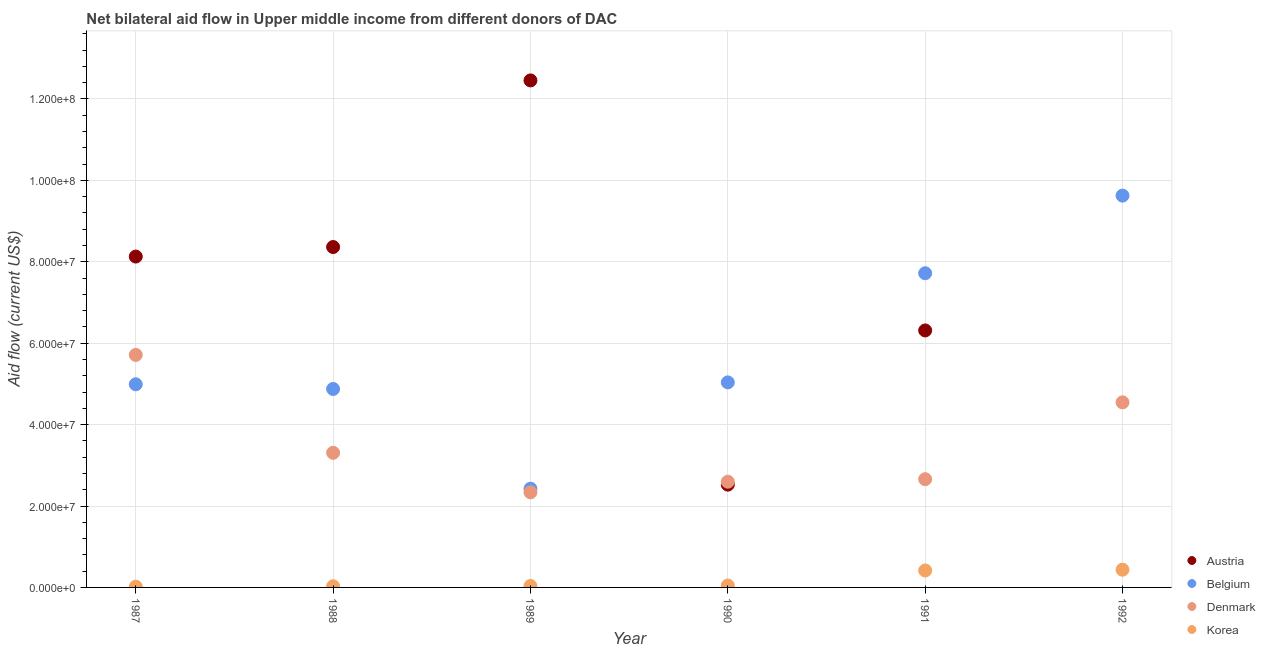Is the number of dotlines equal to the number of legend labels?
Offer a terse response. No. What is the amount of aid given by austria in 1987?
Your answer should be very brief. 8.13e+07. Across all years, what is the maximum amount of aid given by korea?
Ensure brevity in your answer.  4.35e+06. Across all years, what is the minimum amount of aid given by korea?
Your answer should be compact. 1.80e+05. What is the total amount of aid given by austria in the graph?
Your answer should be very brief. 3.78e+08. What is the difference between the amount of aid given by denmark in 1988 and that in 1990?
Ensure brevity in your answer.  7.10e+06. What is the difference between the amount of aid given by korea in 1989 and the amount of aid given by austria in 1990?
Your answer should be compact. -2.49e+07. What is the average amount of aid given by korea per year?
Your answer should be very brief. 1.64e+06. In the year 1992, what is the difference between the amount of aid given by korea and amount of aid given by belgium?
Offer a very short reply. -9.19e+07. What is the ratio of the amount of aid given by korea in 1987 to that in 1991?
Keep it short and to the point. 0.04. Is the amount of aid given by austria in 1988 less than that in 1989?
Your answer should be compact. Yes. Is the difference between the amount of aid given by austria in 1987 and 1990 greater than the difference between the amount of aid given by denmark in 1987 and 1990?
Your answer should be very brief. Yes. What is the difference between the highest and the second highest amount of aid given by korea?
Your answer should be compact. 1.90e+05. What is the difference between the highest and the lowest amount of aid given by denmark?
Make the answer very short. 3.37e+07. In how many years, is the amount of aid given by belgium greater than the average amount of aid given by belgium taken over all years?
Your answer should be very brief. 2. Is the sum of the amount of aid given by austria in 1990 and 1991 greater than the maximum amount of aid given by belgium across all years?
Ensure brevity in your answer.  No. Is it the case that in every year, the sum of the amount of aid given by austria and amount of aid given by belgium is greater than the amount of aid given by denmark?
Give a very brief answer. Yes. Is the amount of aid given by korea strictly less than the amount of aid given by denmark over the years?
Keep it short and to the point. Yes. How many years are there in the graph?
Offer a very short reply. 6. Are the values on the major ticks of Y-axis written in scientific E-notation?
Give a very brief answer. Yes. Does the graph contain grids?
Make the answer very short. Yes. How many legend labels are there?
Your answer should be very brief. 4. What is the title of the graph?
Provide a short and direct response. Net bilateral aid flow in Upper middle income from different donors of DAC. Does "Regional development banks" appear as one of the legend labels in the graph?
Provide a short and direct response. No. What is the label or title of the X-axis?
Offer a very short reply. Year. What is the Aid flow (current US$) in Austria in 1987?
Ensure brevity in your answer.  8.13e+07. What is the Aid flow (current US$) of Belgium in 1987?
Provide a short and direct response. 4.99e+07. What is the Aid flow (current US$) in Denmark in 1987?
Offer a very short reply. 5.71e+07. What is the Aid flow (current US$) of Korea in 1987?
Provide a short and direct response. 1.80e+05. What is the Aid flow (current US$) of Austria in 1988?
Offer a terse response. 8.36e+07. What is the Aid flow (current US$) of Belgium in 1988?
Keep it short and to the point. 4.88e+07. What is the Aid flow (current US$) in Denmark in 1988?
Your answer should be compact. 3.31e+07. What is the Aid flow (current US$) in Korea in 1988?
Give a very brief answer. 2.90e+05. What is the Aid flow (current US$) in Austria in 1989?
Offer a terse response. 1.25e+08. What is the Aid flow (current US$) in Belgium in 1989?
Keep it short and to the point. 2.42e+07. What is the Aid flow (current US$) of Denmark in 1989?
Make the answer very short. 2.34e+07. What is the Aid flow (current US$) in Austria in 1990?
Offer a terse response. 2.52e+07. What is the Aid flow (current US$) in Belgium in 1990?
Provide a short and direct response. 5.04e+07. What is the Aid flow (current US$) in Denmark in 1990?
Your answer should be compact. 2.60e+07. What is the Aid flow (current US$) in Korea in 1990?
Provide a succinct answer. 4.70e+05. What is the Aid flow (current US$) in Austria in 1991?
Give a very brief answer. 6.31e+07. What is the Aid flow (current US$) in Belgium in 1991?
Provide a succinct answer. 7.72e+07. What is the Aid flow (current US$) of Denmark in 1991?
Provide a succinct answer. 2.66e+07. What is the Aid flow (current US$) in Korea in 1991?
Provide a short and direct response. 4.16e+06. What is the Aid flow (current US$) in Austria in 1992?
Provide a short and direct response. 0. What is the Aid flow (current US$) in Belgium in 1992?
Offer a terse response. 9.62e+07. What is the Aid flow (current US$) in Denmark in 1992?
Ensure brevity in your answer.  4.55e+07. What is the Aid flow (current US$) in Korea in 1992?
Your response must be concise. 4.35e+06. Across all years, what is the maximum Aid flow (current US$) in Austria?
Your answer should be compact. 1.25e+08. Across all years, what is the maximum Aid flow (current US$) in Belgium?
Provide a short and direct response. 9.62e+07. Across all years, what is the maximum Aid flow (current US$) of Denmark?
Give a very brief answer. 5.71e+07. Across all years, what is the maximum Aid flow (current US$) in Korea?
Your answer should be very brief. 4.35e+06. Across all years, what is the minimum Aid flow (current US$) of Austria?
Offer a terse response. 0. Across all years, what is the minimum Aid flow (current US$) of Belgium?
Your response must be concise. 2.42e+07. Across all years, what is the minimum Aid flow (current US$) of Denmark?
Provide a succinct answer. 2.34e+07. What is the total Aid flow (current US$) in Austria in the graph?
Offer a very short reply. 3.78e+08. What is the total Aid flow (current US$) in Belgium in the graph?
Provide a short and direct response. 3.47e+08. What is the total Aid flow (current US$) of Denmark in the graph?
Provide a short and direct response. 2.12e+08. What is the total Aid flow (current US$) of Korea in the graph?
Keep it short and to the point. 9.81e+06. What is the difference between the Aid flow (current US$) in Austria in 1987 and that in 1988?
Ensure brevity in your answer.  -2.34e+06. What is the difference between the Aid flow (current US$) of Belgium in 1987 and that in 1988?
Ensure brevity in your answer.  1.15e+06. What is the difference between the Aid flow (current US$) in Denmark in 1987 and that in 1988?
Give a very brief answer. 2.40e+07. What is the difference between the Aid flow (current US$) in Austria in 1987 and that in 1989?
Provide a short and direct response. -4.33e+07. What is the difference between the Aid flow (current US$) of Belgium in 1987 and that in 1989?
Offer a terse response. 2.56e+07. What is the difference between the Aid flow (current US$) of Denmark in 1987 and that in 1989?
Provide a short and direct response. 3.37e+07. What is the difference between the Aid flow (current US$) in Austria in 1987 and that in 1990?
Make the answer very short. 5.60e+07. What is the difference between the Aid flow (current US$) in Belgium in 1987 and that in 1990?
Provide a succinct answer. -4.70e+05. What is the difference between the Aid flow (current US$) of Denmark in 1987 and that in 1990?
Your response must be concise. 3.12e+07. What is the difference between the Aid flow (current US$) in Korea in 1987 and that in 1990?
Give a very brief answer. -2.90e+05. What is the difference between the Aid flow (current US$) in Austria in 1987 and that in 1991?
Provide a short and direct response. 1.82e+07. What is the difference between the Aid flow (current US$) of Belgium in 1987 and that in 1991?
Ensure brevity in your answer.  -2.73e+07. What is the difference between the Aid flow (current US$) in Denmark in 1987 and that in 1991?
Keep it short and to the point. 3.05e+07. What is the difference between the Aid flow (current US$) of Korea in 1987 and that in 1991?
Offer a terse response. -3.98e+06. What is the difference between the Aid flow (current US$) in Belgium in 1987 and that in 1992?
Make the answer very short. -4.64e+07. What is the difference between the Aid flow (current US$) in Denmark in 1987 and that in 1992?
Ensure brevity in your answer.  1.16e+07. What is the difference between the Aid flow (current US$) in Korea in 1987 and that in 1992?
Give a very brief answer. -4.17e+06. What is the difference between the Aid flow (current US$) of Austria in 1988 and that in 1989?
Your answer should be compact. -4.09e+07. What is the difference between the Aid flow (current US$) in Belgium in 1988 and that in 1989?
Your answer should be compact. 2.45e+07. What is the difference between the Aid flow (current US$) of Denmark in 1988 and that in 1989?
Offer a terse response. 9.69e+06. What is the difference between the Aid flow (current US$) of Austria in 1988 and that in 1990?
Provide a succinct answer. 5.84e+07. What is the difference between the Aid flow (current US$) of Belgium in 1988 and that in 1990?
Offer a terse response. -1.62e+06. What is the difference between the Aid flow (current US$) of Denmark in 1988 and that in 1990?
Provide a short and direct response. 7.10e+06. What is the difference between the Aid flow (current US$) of Austria in 1988 and that in 1991?
Your answer should be very brief. 2.05e+07. What is the difference between the Aid flow (current US$) of Belgium in 1988 and that in 1991?
Your answer should be very brief. -2.84e+07. What is the difference between the Aid flow (current US$) of Denmark in 1988 and that in 1991?
Offer a terse response. 6.48e+06. What is the difference between the Aid flow (current US$) in Korea in 1988 and that in 1991?
Keep it short and to the point. -3.87e+06. What is the difference between the Aid flow (current US$) in Belgium in 1988 and that in 1992?
Ensure brevity in your answer.  -4.75e+07. What is the difference between the Aid flow (current US$) of Denmark in 1988 and that in 1992?
Offer a terse response. -1.24e+07. What is the difference between the Aid flow (current US$) in Korea in 1988 and that in 1992?
Keep it short and to the point. -4.06e+06. What is the difference between the Aid flow (current US$) in Austria in 1989 and that in 1990?
Give a very brief answer. 9.93e+07. What is the difference between the Aid flow (current US$) of Belgium in 1989 and that in 1990?
Make the answer very short. -2.61e+07. What is the difference between the Aid flow (current US$) in Denmark in 1989 and that in 1990?
Keep it short and to the point. -2.59e+06. What is the difference between the Aid flow (current US$) in Korea in 1989 and that in 1990?
Provide a short and direct response. -1.10e+05. What is the difference between the Aid flow (current US$) in Austria in 1989 and that in 1991?
Offer a terse response. 6.14e+07. What is the difference between the Aid flow (current US$) of Belgium in 1989 and that in 1991?
Make the answer very short. -5.29e+07. What is the difference between the Aid flow (current US$) in Denmark in 1989 and that in 1991?
Offer a terse response. -3.21e+06. What is the difference between the Aid flow (current US$) of Korea in 1989 and that in 1991?
Offer a terse response. -3.80e+06. What is the difference between the Aid flow (current US$) of Belgium in 1989 and that in 1992?
Give a very brief answer. -7.20e+07. What is the difference between the Aid flow (current US$) in Denmark in 1989 and that in 1992?
Provide a short and direct response. -2.21e+07. What is the difference between the Aid flow (current US$) of Korea in 1989 and that in 1992?
Make the answer very short. -3.99e+06. What is the difference between the Aid flow (current US$) in Austria in 1990 and that in 1991?
Keep it short and to the point. -3.79e+07. What is the difference between the Aid flow (current US$) in Belgium in 1990 and that in 1991?
Offer a very short reply. -2.68e+07. What is the difference between the Aid flow (current US$) of Denmark in 1990 and that in 1991?
Provide a short and direct response. -6.20e+05. What is the difference between the Aid flow (current US$) of Korea in 1990 and that in 1991?
Offer a very short reply. -3.69e+06. What is the difference between the Aid flow (current US$) in Belgium in 1990 and that in 1992?
Provide a succinct answer. -4.59e+07. What is the difference between the Aid flow (current US$) in Denmark in 1990 and that in 1992?
Your answer should be compact. -1.95e+07. What is the difference between the Aid flow (current US$) in Korea in 1990 and that in 1992?
Your response must be concise. -3.88e+06. What is the difference between the Aid flow (current US$) in Belgium in 1991 and that in 1992?
Ensure brevity in your answer.  -1.91e+07. What is the difference between the Aid flow (current US$) of Denmark in 1991 and that in 1992?
Your answer should be very brief. -1.89e+07. What is the difference between the Aid flow (current US$) in Korea in 1991 and that in 1992?
Provide a succinct answer. -1.90e+05. What is the difference between the Aid flow (current US$) of Austria in 1987 and the Aid flow (current US$) of Belgium in 1988?
Give a very brief answer. 3.25e+07. What is the difference between the Aid flow (current US$) of Austria in 1987 and the Aid flow (current US$) of Denmark in 1988?
Give a very brief answer. 4.82e+07. What is the difference between the Aid flow (current US$) in Austria in 1987 and the Aid flow (current US$) in Korea in 1988?
Ensure brevity in your answer.  8.10e+07. What is the difference between the Aid flow (current US$) in Belgium in 1987 and the Aid flow (current US$) in Denmark in 1988?
Give a very brief answer. 1.68e+07. What is the difference between the Aid flow (current US$) in Belgium in 1987 and the Aid flow (current US$) in Korea in 1988?
Offer a very short reply. 4.96e+07. What is the difference between the Aid flow (current US$) in Denmark in 1987 and the Aid flow (current US$) in Korea in 1988?
Give a very brief answer. 5.68e+07. What is the difference between the Aid flow (current US$) of Austria in 1987 and the Aid flow (current US$) of Belgium in 1989?
Offer a terse response. 5.70e+07. What is the difference between the Aid flow (current US$) in Austria in 1987 and the Aid flow (current US$) in Denmark in 1989?
Offer a very short reply. 5.79e+07. What is the difference between the Aid flow (current US$) in Austria in 1987 and the Aid flow (current US$) in Korea in 1989?
Give a very brief answer. 8.09e+07. What is the difference between the Aid flow (current US$) of Belgium in 1987 and the Aid flow (current US$) of Denmark in 1989?
Your response must be concise. 2.65e+07. What is the difference between the Aid flow (current US$) in Belgium in 1987 and the Aid flow (current US$) in Korea in 1989?
Keep it short and to the point. 4.95e+07. What is the difference between the Aid flow (current US$) in Denmark in 1987 and the Aid flow (current US$) in Korea in 1989?
Your response must be concise. 5.68e+07. What is the difference between the Aid flow (current US$) of Austria in 1987 and the Aid flow (current US$) of Belgium in 1990?
Offer a terse response. 3.09e+07. What is the difference between the Aid flow (current US$) in Austria in 1987 and the Aid flow (current US$) in Denmark in 1990?
Ensure brevity in your answer.  5.53e+07. What is the difference between the Aid flow (current US$) of Austria in 1987 and the Aid flow (current US$) of Korea in 1990?
Offer a very short reply. 8.08e+07. What is the difference between the Aid flow (current US$) of Belgium in 1987 and the Aid flow (current US$) of Denmark in 1990?
Give a very brief answer. 2.39e+07. What is the difference between the Aid flow (current US$) in Belgium in 1987 and the Aid flow (current US$) in Korea in 1990?
Make the answer very short. 4.94e+07. What is the difference between the Aid flow (current US$) in Denmark in 1987 and the Aid flow (current US$) in Korea in 1990?
Your answer should be very brief. 5.66e+07. What is the difference between the Aid flow (current US$) in Austria in 1987 and the Aid flow (current US$) in Belgium in 1991?
Offer a terse response. 4.10e+06. What is the difference between the Aid flow (current US$) in Austria in 1987 and the Aid flow (current US$) in Denmark in 1991?
Provide a short and direct response. 5.47e+07. What is the difference between the Aid flow (current US$) in Austria in 1987 and the Aid flow (current US$) in Korea in 1991?
Provide a short and direct response. 7.71e+07. What is the difference between the Aid flow (current US$) of Belgium in 1987 and the Aid flow (current US$) of Denmark in 1991?
Your answer should be very brief. 2.33e+07. What is the difference between the Aid flow (current US$) in Belgium in 1987 and the Aid flow (current US$) in Korea in 1991?
Your answer should be very brief. 4.57e+07. What is the difference between the Aid flow (current US$) of Denmark in 1987 and the Aid flow (current US$) of Korea in 1991?
Keep it short and to the point. 5.30e+07. What is the difference between the Aid flow (current US$) of Austria in 1987 and the Aid flow (current US$) of Belgium in 1992?
Make the answer very short. -1.50e+07. What is the difference between the Aid flow (current US$) of Austria in 1987 and the Aid flow (current US$) of Denmark in 1992?
Your answer should be very brief. 3.58e+07. What is the difference between the Aid flow (current US$) of Austria in 1987 and the Aid flow (current US$) of Korea in 1992?
Your response must be concise. 7.69e+07. What is the difference between the Aid flow (current US$) of Belgium in 1987 and the Aid flow (current US$) of Denmark in 1992?
Give a very brief answer. 4.43e+06. What is the difference between the Aid flow (current US$) of Belgium in 1987 and the Aid flow (current US$) of Korea in 1992?
Your answer should be very brief. 4.56e+07. What is the difference between the Aid flow (current US$) of Denmark in 1987 and the Aid flow (current US$) of Korea in 1992?
Keep it short and to the point. 5.28e+07. What is the difference between the Aid flow (current US$) in Austria in 1988 and the Aid flow (current US$) in Belgium in 1989?
Keep it short and to the point. 5.94e+07. What is the difference between the Aid flow (current US$) of Austria in 1988 and the Aid flow (current US$) of Denmark in 1989?
Your response must be concise. 6.02e+07. What is the difference between the Aid flow (current US$) of Austria in 1988 and the Aid flow (current US$) of Korea in 1989?
Your response must be concise. 8.33e+07. What is the difference between the Aid flow (current US$) of Belgium in 1988 and the Aid flow (current US$) of Denmark in 1989?
Ensure brevity in your answer.  2.54e+07. What is the difference between the Aid flow (current US$) of Belgium in 1988 and the Aid flow (current US$) of Korea in 1989?
Provide a short and direct response. 4.84e+07. What is the difference between the Aid flow (current US$) in Denmark in 1988 and the Aid flow (current US$) in Korea in 1989?
Make the answer very short. 3.27e+07. What is the difference between the Aid flow (current US$) in Austria in 1988 and the Aid flow (current US$) in Belgium in 1990?
Your answer should be compact. 3.32e+07. What is the difference between the Aid flow (current US$) of Austria in 1988 and the Aid flow (current US$) of Denmark in 1990?
Keep it short and to the point. 5.76e+07. What is the difference between the Aid flow (current US$) of Austria in 1988 and the Aid flow (current US$) of Korea in 1990?
Your response must be concise. 8.32e+07. What is the difference between the Aid flow (current US$) of Belgium in 1988 and the Aid flow (current US$) of Denmark in 1990?
Give a very brief answer. 2.28e+07. What is the difference between the Aid flow (current US$) in Belgium in 1988 and the Aid flow (current US$) in Korea in 1990?
Your response must be concise. 4.83e+07. What is the difference between the Aid flow (current US$) of Denmark in 1988 and the Aid flow (current US$) of Korea in 1990?
Ensure brevity in your answer.  3.26e+07. What is the difference between the Aid flow (current US$) in Austria in 1988 and the Aid flow (current US$) in Belgium in 1991?
Keep it short and to the point. 6.44e+06. What is the difference between the Aid flow (current US$) of Austria in 1988 and the Aid flow (current US$) of Denmark in 1991?
Offer a terse response. 5.70e+07. What is the difference between the Aid flow (current US$) in Austria in 1988 and the Aid flow (current US$) in Korea in 1991?
Your answer should be compact. 7.95e+07. What is the difference between the Aid flow (current US$) in Belgium in 1988 and the Aid flow (current US$) in Denmark in 1991?
Provide a short and direct response. 2.22e+07. What is the difference between the Aid flow (current US$) in Belgium in 1988 and the Aid flow (current US$) in Korea in 1991?
Provide a short and direct response. 4.46e+07. What is the difference between the Aid flow (current US$) of Denmark in 1988 and the Aid flow (current US$) of Korea in 1991?
Make the answer very short. 2.89e+07. What is the difference between the Aid flow (current US$) in Austria in 1988 and the Aid flow (current US$) in Belgium in 1992?
Offer a terse response. -1.26e+07. What is the difference between the Aid flow (current US$) in Austria in 1988 and the Aid flow (current US$) in Denmark in 1992?
Your response must be concise. 3.82e+07. What is the difference between the Aid flow (current US$) in Austria in 1988 and the Aid flow (current US$) in Korea in 1992?
Make the answer very short. 7.93e+07. What is the difference between the Aid flow (current US$) in Belgium in 1988 and the Aid flow (current US$) in Denmark in 1992?
Keep it short and to the point. 3.28e+06. What is the difference between the Aid flow (current US$) in Belgium in 1988 and the Aid flow (current US$) in Korea in 1992?
Your answer should be compact. 4.44e+07. What is the difference between the Aid flow (current US$) in Denmark in 1988 and the Aid flow (current US$) in Korea in 1992?
Offer a very short reply. 2.87e+07. What is the difference between the Aid flow (current US$) of Austria in 1989 and the Aid flow (current US$) of Belgium in 1990?
Provide a short and direct response. 7.42e+07. What is the difference between the Aid flow (current US$) in Austria in 1989 and the Aid flow (current US$) in Denmark in 1990?
Your answer should be very brief. 9.86e+07. What is the difference between the Aid flow (current US$) in Austria in 1989 and the Aid flow (current US$) in Korea in 1990?
Make the answer very short. 1.24e+08. What is the difference between the Aid flow (current US$) of Belgium in 1989 and the Aid flow (current US$) of Denmark in 1990?
Keep it short and to the point. -1.72e+06. What is the difference between the Aid flow (current US$) of Belgium in 1989 and the Aid flow (current US$) of Korea in 1990?
Give a very brief answer. 2.38e+07. What is the difference between the Aid flow (current US$) in Denmark in 1989 and the Aid flow (current US$) in Korea in 1990?
Your answer should be very brief. 2.29e+07. What is the difference between the Aid flow (current US$) in Austria in 1989 and the Aid flow (current US$) in Belgium in 1991?
Your answer should be compact. 4.74e+07. What is the difference between the Aid flow (current US$) in Austria in 1989 and the Aid flow (current US$) in Denmark in 1991?
Make the answer very short. 9.80e+07. What is the difference between the Aid flow (current US$) of Austria in 1989 and the Aid flow (current US$) of Korea in 1991?
Your response must be concise. 1.20e+08. What is the difference between the Aid flow (current US$) of Belgium in 1989 and the Aid flow (current US$) of Denmark in 1991?
Provide a short and direct response. -2.34e+06. What is the difference between the Aid flow (current US$) of Belgium in 1989 and the Aid flow (current US$) of Korea in 1991?
Give a very brief answer. 2.01e+07. What is the difference between the Aid flow (current US$) in Denmark in 1989 and the Aid flow (current US$) in Korea in 1991?
Offer a very short reply. 1.92e+07. What is the difference between the Aid flow (current US$) in Austria in 1989 and the Aid flow (current US$) in Belgium in 1992?
Keep it short and to the point. 2.83e+07. What is the difference between the Aid flow (current US$) of Austria in 1989 and the Aid flow (current US$) of Denmark in 1992?
Give a very brief answer. 7.91e+07. What is the difference between the Aid flow (current US$) in Austria in 1989 and the Aid flow (current US$) in Korea in 1992?
Keep it short and to the point. 1.20e+08. What is the difference between the Aid flow (current US$) in Belgium in 1989 and the Aid flow (current US$) in Denmark in 1992?
Offer a terse response. -2.12e+07. What is the difference between the Aid flow (current US$) in Belgium in 1989 and the Aid flow (current US$) in Korea in 1992?
Provide a short and direct response. 1.99e+07. What is the difference between the Aid flow (current US$) of Denmark in 1989 and the Aid flow (current US$) of Korea in 1992?
Offer a very short reply. 1.90e+07. What is the difference between the Aid flow (current US$) in Austria in 1990 and the Aid flow (current US$) in Belgium in 1991?
Ensure brevity in your answer.  -5.19e+07. What is the difference between the Aid flow (current US$) of Austria in 1990 and the Aid flow (current US$) of Denmark in 1991?
Offer a terse response. -1.34e+06. What is the difference between the Aid flow (current US$) in Austria in 1990 and the Aid flow (current US$) in Korea in 1991?
Provide a short and direct response. 2.11e+07. What is the difference between the Aid flow (current US$) of Belgium in 1990 and the Aid flow (current US$) of Denmark in 1991?
Your response must be concise. 2.38e+07. What is the difference between the Aid flow (current US$) in Belgium in 1990 and the Aid flow (current US$) in Korea in 1991?
Ensure brevity in your answer.  4.62e+07. What is the difference between the Aid flow (current US$) in Denmark in 1990 and the Aid flow (current US$) in Korea in 1991?
Ensure brevity in your answer.  2.18e+07. What is the difference between the Aid flow (current US$) in Austria in 1990 and the Aid flow (current US$) in Belgium in 1992?
Provide a short and direct response. -7.10e+07. What is the difference between the Aid flow (current US$) in Austria in 1990 and the Aid flow (current US$) in Denmark in 1992?
Make the answer very short. -2.02e+07. What is the difference between the Aid flow (current US$) of Austria in 1990 and the Aid flow (current US$) of Korea in 1992?
Provide a short and direct response. 2.09e+07. What is the difference between the Aid flow (current US$) in Belgium in 1990 and the Aid flow (current US$) in Denmark in 1992?
Keep it short and to the point. 4.90e+06. What is the difference between the Aid flow (current US$) in Belgium in 1990 and the Aid flow (current US$) in Korea in 1992?
Provide a short and direct response. 4.60e+07. What is the difference between the Aid flow (current US$) in Denmark in 1990 and the Aid flow (current US$) in Korea in 1992?
Offer a very short reply. 2.16e+07. What is the difference between the Aid flow (current US$) in Austria in 1991 and the Aid flow (current US$) in Belgium in 1992?
Keep it short and to the point. -3.31e+07. What is the difference between the Aid flow (current US$) in Austria in 1991 and the Aid flow (current US$) in Denmark in 1992?
Provide a succinct answer. 1.77e+07. What is the difference between the Aid flow (current US$) of Austria in 1991 and the Aid flow (current US$) of Korea in 1992?
Provide a succinct answer. 5.88e+07. What is the difference between the Aid flow (current US$) in Belgium in 1991 and the Aid flow (current US$) in Denmark in 1992?
Give a very brief answer. 3.17e+07. What is the difference between the Aid flow (current US$) of Belgium in 1991 and the Aid flow (current US$) of Korea in 1992?
Your response must be concise. 7.28e+07. What is the difference between the Aid flow (current US$) of Denmark in 1991 and the Aid flow (current US$) of Korea in 1992?
Ensure brevity in your answer.  2.22e+07. What is the average Aid flow (current US$) in Austria per year?
Keep it short and to the point. 6.30e+07. What is the average Aid flow (current US$) in Belgium per year?
Your answer should be compact. 5.78e+07. What is the average Aid flow (current US$) in Denmark per year?
Give a very brief answer. 3.53e+07. What is the average Aid flow (current US$) of Korea per year?
Your response must be concise. 1.64e+06. In the year 1987, what is the difference between the Aid flow (current US$) in Austria and Aid flow (current US$) in Belgium?
Provide a short and direct response. 3.14e+07. In the year 1987, what is the difference between the Aid flow (current US$) of Austria and Aid flow (current US$) of Denmark?
Ensure brevity in your answer.  2.42e+07. In the year 1987, what is the difference between the Aid flow (current US$) in Austria and Aid flow (current US$) in Korea?
Provide a succinct answer. 8.11e+07. In the year 1987, what is the difference between the Aid flow (current US$) of Belgium and Aid flow (current US$) of Denmark?
Give a very brief answer. -7.22e+06. In the year 1987, what is the difference between the Aid flow (current US$) in Belgium and Aid flow (current US$) in Korea?
Keep it short and to the point. 4.97e+07. In the year 1987, what is the difference between the Aid flow (current US$) in Denmark and Aid flow (current US$) in Korea?
Offer a terse response. 5.69e+07. In the year 1988, what is the difference between the Aid flow (current US$) of Austria and Aid flow (current US$) of Belgium?
Give a very brief answer. 3.49e+07. In the year 1988, what is the difference between the Aid flow (current US$) of Austria and Aid flow (current US$) of Denmark?
Ensure brevity in your answer.  5.06e+07. In the year 1988, what is the difference between the Aid flow (current US$) in Austria and Aid flow (current US$) in Korea?
Give a very brief answer. 8.33e+07. In the year 1988, what is the difference between the Aid flow (current US$) in Belgium and Aid flow (current US$) in Denmark?
Offer a terse response. 1.57e+07. In the year 1988, what is the difference between the Aid flow (current US$) of Belgium and Aid flow (current US$) of Korea?
Ensure brevity in your answer.  4.85e+07. In the year 1988, what is the difference between the Aid flow (current US$) of Denmark and Aid flow (current US$) of Korea?
Your response must be concise. 3.28e+07. In the year 1989, what is the difference between the Aid flow (current US$) of Austria and Aid flow (current US$) of Belgium?
Make the answer very short. 1.00e+08. In the year 1989, what is the difference between the Aid flow (current US$) in Austria and Aid flow (current US$) in Denmark?
Your answer should be compact. 1.01e+08. In the year 1989, what is the difference between the Aid flow (current US$) of Austria and Aid flow (current US$) of Korea?
Ensure brevity in your answer.  1.24e+08. In the year 1989, what is the difference between the Aid flow (current US$) of Belgium and Aid flow (current US$) of Denmark?
Provide a short and direct response. 8.70e+05. In the year 1989, what is the difference between the Aid flow (current US$) of Belgium and Aid flow (current US$) of Korea?
Ensure brevity in your answer.  2.39e+07. In the year 1989, what is the difference between the Aid flow (current US$) in Denmark and Aid flow (current US$) in Korea?
Offer a terse response. 2.30e+07. In the year 1990, what is the difference between the Aid flow (current US$) in Austria and Aid flow (current US$) in Belgium?
Provide a short and direct response. -2.51e+07. In the year 1990, what is the difference between the Aid flow (current US$) of Austria and Aid flow (current US$) of Denmark?
Make the answer very short. -7.20e+05. In the year 1990, what is the difference between the Aid flow (current US$) in Austria and Aid flow (current US$) in Korea?
Keep it short and to the point. 2.48e+07. In the year 1990, what is the difference between the Aid flow (current US$) of Belgium and Aid flow (current US$) of Denmark?
Provide a short and direct response. 2.44e+07. In the year 1990, what is the difference between the Aid flow (current US$) in Belgium and Aid flow (current US$) in Korea?
Offer a terse response. 4.99e+07. In the year 1990, what is the difference between the Aid flow (current US$) of Denmark and Aid flow (current US$) of Korea?
Offer a very short reply. 2.55e+07. In the year 1991, what is the difference between the Aid flow (current US$) in Austria and Aid flow (current US$) in Belgium?
Your response must be concise. -1.40e+07. In the year 1991, what is the difference between the Aid flow (current US$) in Austria and Aid flow (current US$) in Denmark?
Provide a short and direct response. 3.65e+07. In the year 1991, what is the difference between the Aid flow (current US$) of Austria and Aid flow (current US$) of Korea?
Offer a very short reply. 5.90e+07. In the year 1991, what is the difference between the Aid flow (current US$) of Belgium and Aid flow (current US$) of Denmark?
Ensure brevity in your answer.  5.06e+07. In the year 1991, what is the difference between the Aid flow (current US$) of Belgium and Aid flow (current US$) of Korea?
Your response must be concise. 7.30e+07. In the year 1991, what is the difference between the Aid flow (current US$) in Denmark and Aid flow (current US$) in Korea?
Give a very brief answer. 2.24e+07. In the year 1992, what is the difference between the Aid flow (current US$) of Belgium and Aid flow (current US$) of Denmark?
Your answer should be compact. 5.08e+07. In the year 1992, what is the difference between the Aid flow (current US$) of Belgium and Aid flow (current US$) of Korea?
Offer a very short reply. 9.19e+07. In the year 1992, what is the difference between the Aid flow (current US$) of Denmark and Aid flow (current US$) of Korea?
Offer a terse response. 4.11e+07. What is the ratio of the Aid flow (current US$) of Belgium in 1987 to that in 1988?
Keep it short and to the point. 1.02. What is the ratio of the Aid flow (current US$) in Denmark in 1987 to that in 1988?
Provide a succinct answer. 1.73. What is the ratio of the Aid flow (current US$) in Korea in 1987 to that in 1988?
Offer a terse response. 0.62. What is the ratio of the Aid flow (current US$) of Austria in 1987 to that in 1989?
Your response must be concise. 0.65. What is the ratio of the Aid flow (current US$) of Belgium in 1987 to that in 1989?
Your answer should be compact. 2.06. What is the ratio of the Aid flow (current US$) of Denmark in 1987 to that in 1989?
Provide a short and direct response. 2.44. What is the ratio of the Aid flow (current US$) of Austria in 1987 to that in 1990?
Provide a succinct answer. 3.22. What is the ratio of the Aid flow (current US$) in Denmark in 1987 to that in 1990?
Provide a short and direct response. 2.2. What is the ratio of the Aid flow (current US$) in Korea in 1987 to that in 1990?
Ensure brevity in your answer.  0.38. What is the ratio of the Aid flow (current US$) of Austria in 1987 to that in 1991?
Your answer should be compact. 1.29. What is the ratio of the Aid flow (current US$) in Belgium in 1987 to that in 1991?
Ensure brevity in your answer.  0.65. What is the ratio of the Aid flow (current US$) of Denmark in 1987 to that in 1991?
Your answer should be compact. 2.15. What is the ratio of the Aid flow (current US$) of Korea in 1987 to that in 1991?
Keep it short and to the point. 0.04. What is the ratio of the Aid flow (current US$) in Belgium in 1987 to that in 1992?
Keep it short and to the point. 0.52. What is the ratio of the Aid flow (current US$) of Denmark in 1987 to that in 1992?
Your answer should be compact. 1.26. What is the ratio of the Aid flow (current US$) in Korea in 1987 to that in 1992?
Your response must be concise. 0.04. What is the ratio of the Aid flow (current US$) of Austria in 1988 to that in 1989?
Ensure brevity in your answer.  0.67. What is the ratio of the Aid flow (current US$) in Belgium in 1988 to that in 1989?
Keep it short and to the point. 2.01. What is the ratio of the Aid flow (current US$) in Denmark in 1988 to that in 1989?
Your answer should be compact. 1.41. What is the ratio of the Aid flow (current US$) in Korea in 1988 to that in 1989?
Provide a succinct answer. 0.81. What is the ratio of the Aid flow (current US$) in Austria in 1988 to that in 1990?
Ensure brevity in your answer.  3.31. What is the ratio of the Aid flow (current US$) in Belgium in 1988 to that in 1990?
Your answer should be very brief. 0.97. What is the ratio of the Aid flow (current US$) of Denmark in 1988 to that in 1990?
Provide a succinct answer. 1.27. What is the ratio of the Aid flow (current US$) in Korea in 1988 to that in 1990?
Make the answer very short. 0.62. What is the ratio of the Aid flow (current US$) of Austria in 1988 to that in 1991?
Your answer should be very brief. 1.32. What is the ratio of the Aid flow (current US$) of Belgium in 1988 to that in 1991?
Ensure brevity in your answer.  0.63. What is the ratio of the Aid flow (current US$) of Denmark in 1988 to that in 1991?
Your response must be concise. 1.24. What is the ratio of the Aid flow (current US$) of Korea in 1988 to that in 1991?
Provide a short and direct response. 0.07. What is the ratio of the Aid flow (current US$) of Belgium in 1988 to that in 1992?
Make the answer very short. 0.51. What is the ratio of the Aid flow (current US$) of Denmark in 1988 to that in 1992?
Keep it short and to the point. 0.73. What is the ratio of the Aid flow (current US$) in Korea in 1988 to that in 1992?
Ensure brevity in your answer.  0.07. What is the ratio of the Aid flow (current US$) of Austria in 1989 to that in 1990?
Keep it short and to the point. 4.93. What is the ratio of the Aid flow (current US$) in Belgium in 1989 to that in 1990?
Offer a very short reply. 0.48. What is the ratio of the Aid flow (current US$) of Denmark in 1989 to that in 1990?
Offer a terse response. 0.9. What is the ratio of the Aid flow (current US$) in Korea in 1989 to that in 1990?
Ensure brevity in your answer.  0.77. What is the ratio of the Aid flow (current US$) in Austria in 1989 to that in 1991?
Offer a terse response. 1.97. What is the ratio of the Aid flow (current US$) in Belgium in 1989 to that in 1991?
Your response must be concise. 0.31. What is the ratio of the Aid flow (current US$) in Denmark in 1989 to that in 1991?
Offer a terse response. 0.88. What is the ratio of the Aid flow (current US$) in Korea in 1989 to that in 1991?
Offer a very short reply. 0.09. What is the ratio of the Aid flow (current US$) of Belgium in 1989 to that in 1992?
Your answer should be very brief. 0.25. What is the ratio of the Aid flow (current US$) in Denmark in 1989 to that in 1992?
Your response must be concise. 0.51. What is the ratio of the Aid flow (current US$) of Korea in 1989 to that in 1992?
Offer a terse response. 0.08. What is the ratio of the Aid flow (current US$) of Belgium in 1990 to that in 1991?
Ensure brevity in your answer.  0.65. What is the ratio of the Aid flow (current US$) in Denmark in 1990 to that in 1991?
Give a very brief answer. 0.98. What is the ratio of the Aid flow (current US$) of Korea in 1990 to that in 1991?
Offer a very short reply. 0.11. What is the ratio of the Aid flow (current US$) of Belgium in 1990 to that in 1992?
Offer a very short reply. 0.52. What is the ratio of the Aid flow (current US$) in Denmark in 1990 to that in 1992?
Offer a very short reply. 0.57. What is the ratio of the Aid flow (current US$) of Korea in 1990 to that in 1992?
Your answer should be very brief. 0.11. What is the ratio of the Aid flow (current US$) in Belgium in 1991 to that in 1992?
Your response must be concise. 0.8. What is the ratio of the Aid flow (current US$) in Denmark in 1991 to that in 1992?
Provide a short and direct response. 0.58. What is the ratio of the Aid flow (current US$) in Korea in 1991 to that in 1992?
Offer a terse response. 0.96. What is the difference between the highest and the second highest Aid flow (current US$) of Austria?
Your answer should be very brief. 4.09e+07. What is the difference between the highest and the second highest Aid flow (current US$) in Belgium?
Offer a terse response. 1.91e+07. What is the difference between the highest and the second highest Aid flow (current US$) of Denmark?
Keep it short and to the point. 1.16e+07. What is the difference between the highest and the lowest Aid flow (current US$) in Austria?
Provide a succinct answer. 1.25e+08. What is the difference between the highest and the lowest Aid flow (current US$) of Belgium?
Your answer should be compact. 7.20e+07. What is the difference between the highest and the lowest Aid flow (current US$) of Denmark?
Provide a short and direct response. 3.37e+07. What is the difference between the highest and the lowest Aid flow (current US$) of Korea?
Keep it short and to the point. 4.17e+06. 